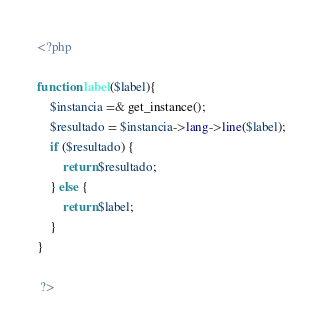<code> <loc_0><loc_0><loc_500><loc_500><_PHP_><?php 

function label($label){
	$instancia =& get_instance();
	$resultado = $instancia->lang->line($label);
	if ($resultado) {
		return $resultado;
	} else {
		return $label;
	}
}

 ?></code> 